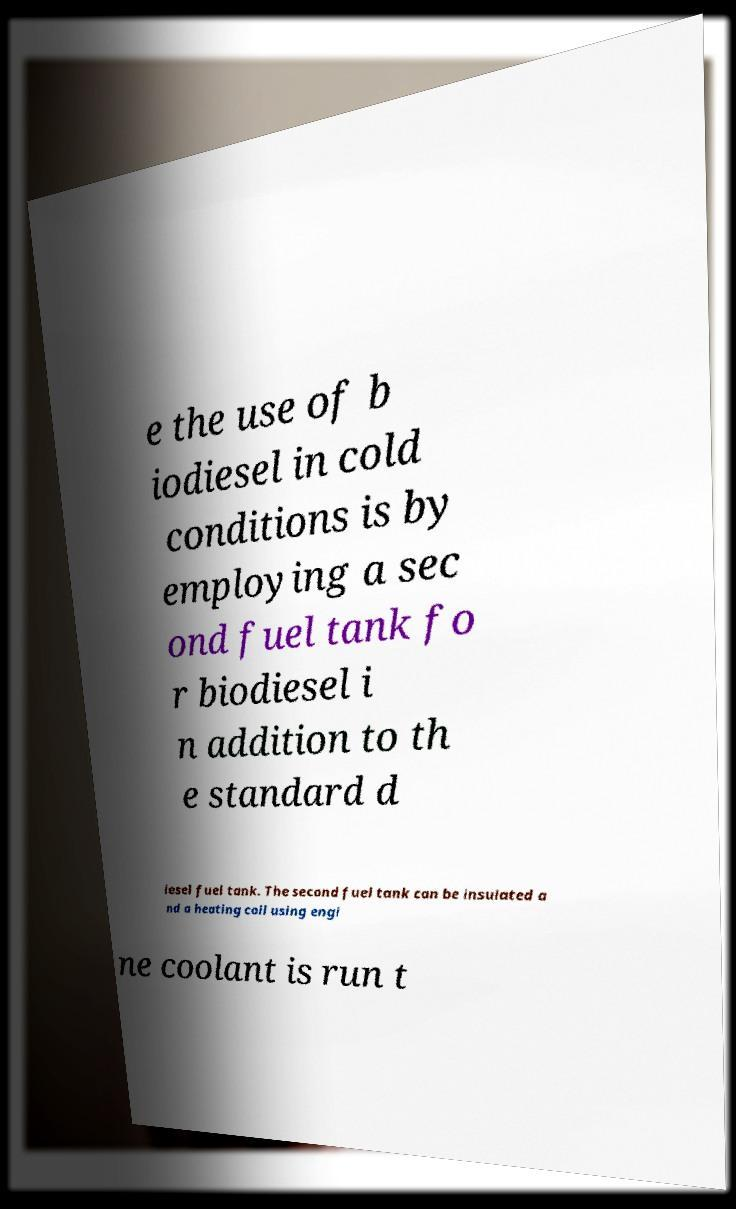Can you accurately transcribe the text from the provided image for me? e the use of b iodiesel in cold conditions is by employing a sec ond fuel tank fo r biodiesel i n addition to th e standard d iesel fuel tank. The second fuel tank can be insulated a nd a heating coil using engi ne coolant is run t 